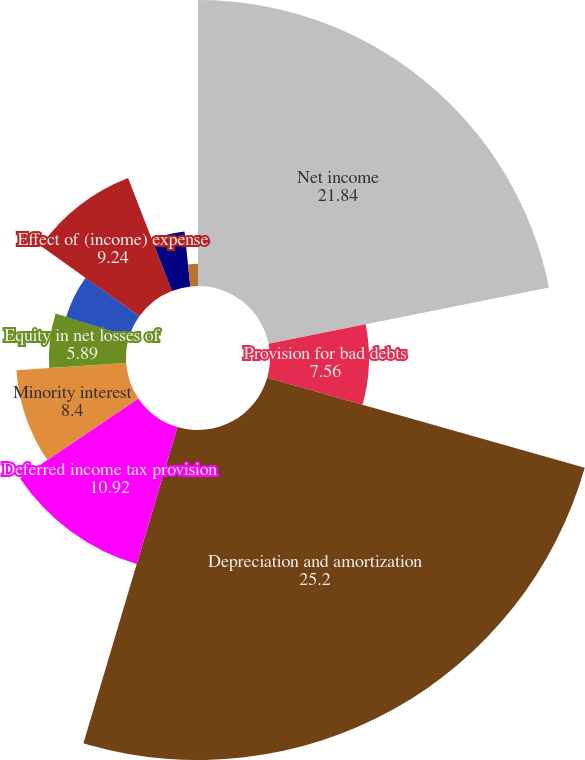<chart> <loc_0><loc_0><loc_500><loc_500><pie_chart><fcel>Net income<fcel>Provision for bad debts<fcel>Depreciation and amortization<fcel>Deferred income tax provision<fcel>Minority interest<fcel>Equity in net losses of<fcel>Net gain from disposal of<fcel>Effect of (income) expense<fcel>Receivables<fcel>Other current assets<nl><fcel>21.84%<fcel>7.56%<fcel>25.2%<fcel>10.92%<fcel>8.4%<fcel>5.89%<fcel>5.05%<fcel>9.24%<fcel>4.21%<fcel>1.69%<nl></chart> 